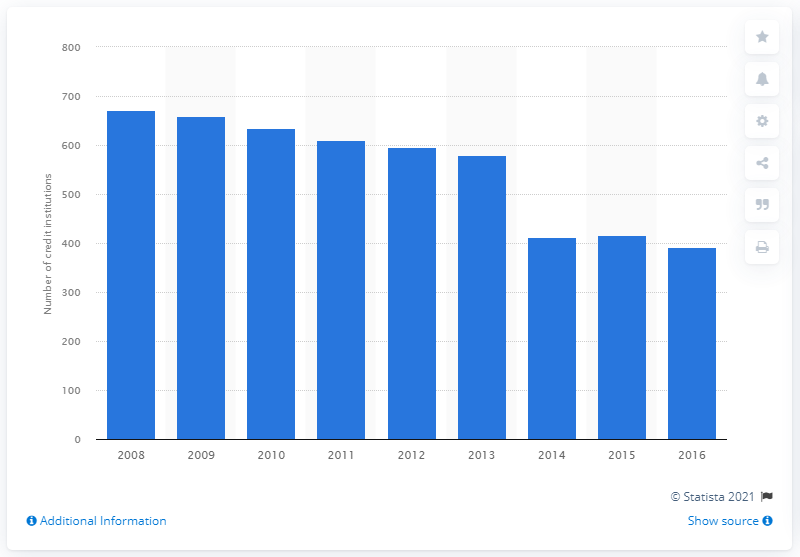Mention a couple of crucial points in this snapshot. There were 391 microfinance institutions active in France in 2016. 